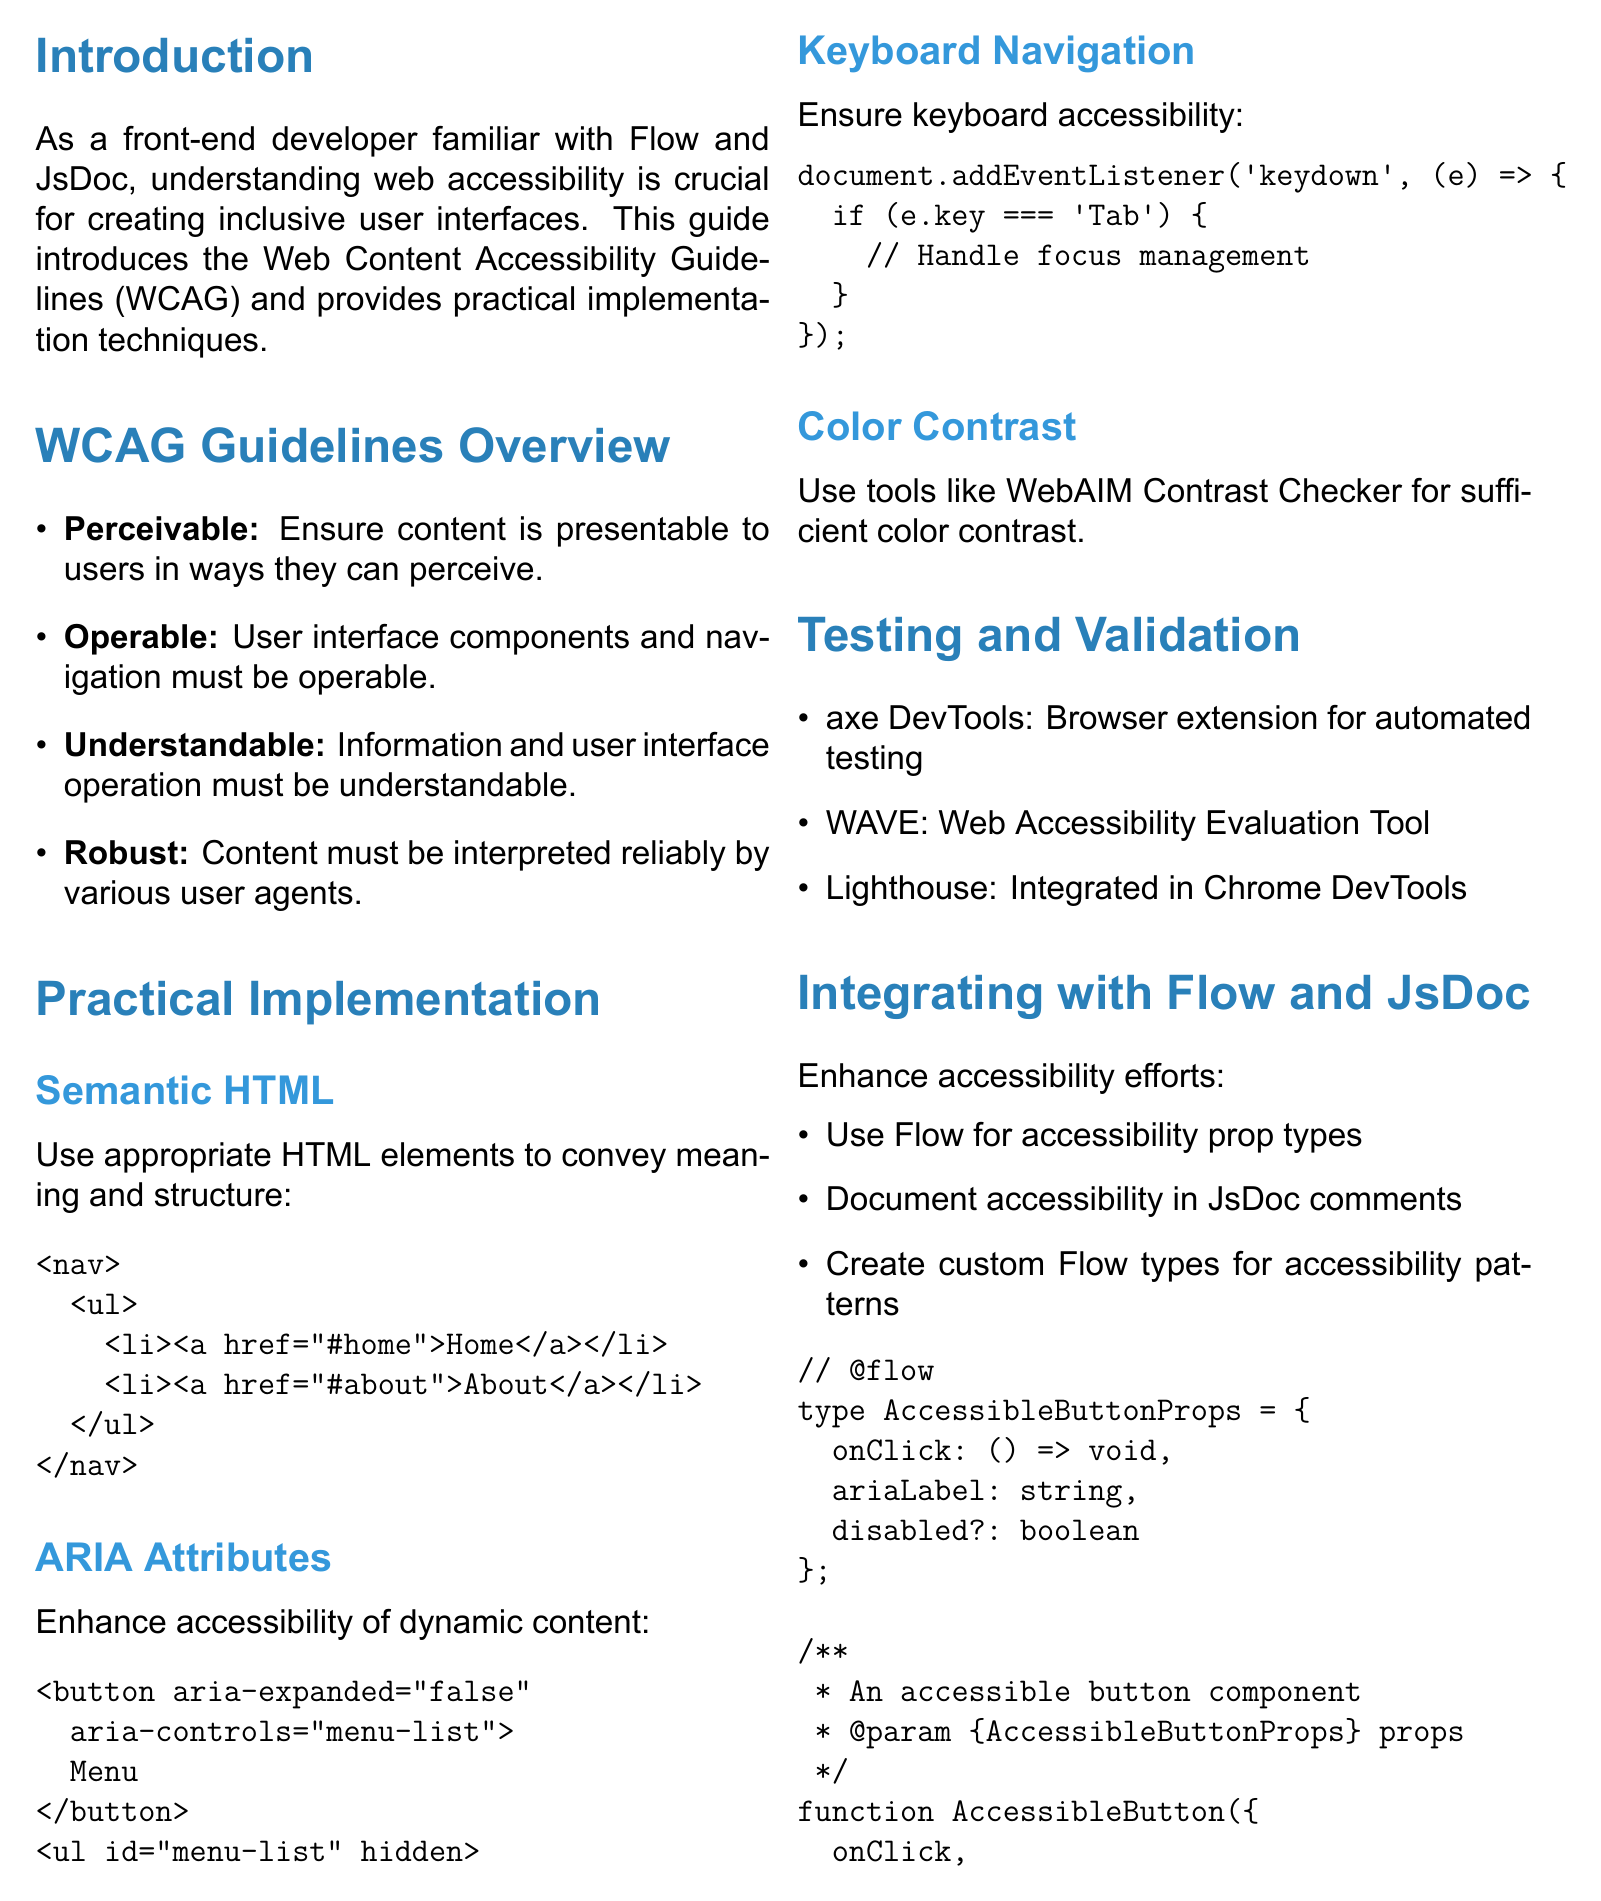what is the title of the brochure? The title is provided at the beginning of the document, which is "Accessibility in Web Design: A Front-End Developer's Guide."
Answer: Accessibility in Web Design: A Front-End Developer's Guide how many guidelines are detailed in the WCAG overview section? The document lists four guidelines under the WCAG overview section, which are Perceivable, Operable, Understandable, and Robust.
Answer: four which tool is mentioned for automated accessibility testing? The document lists "axe DevTools" as a browser extension for automated accessibility testing.
Answer: axe DevTools what is the name of the resource for further learning about accessibility? One of the resources listed for further learning is "MDN Web Docs: Accessibility."
Answer: MDN Web Docs: Accessibility what HTML elements should you use according to Semantic HTML technique? The document specifies using appropriate HTML elements such as <nav>, <main>, and <article> to convey meaning and structure.
Answer: <nav>, <main>, and <article> what is the purpose of ARIA attributes? ARIA attributes are implemented to enhance the accessibility of dynamic content and complex UI components.
Answer: enhance accessibility of dynamic content how can Flow enhance your accessibility efforts? Flow can be used to define prop types for accessibility attributes in React components.
Answer: define prop types for accessibility attributes what should be ensured for keyboard navigation? It is essential to ensure that all interactive elements are accessible via keyboard.
Answer: accessible via keyboard 